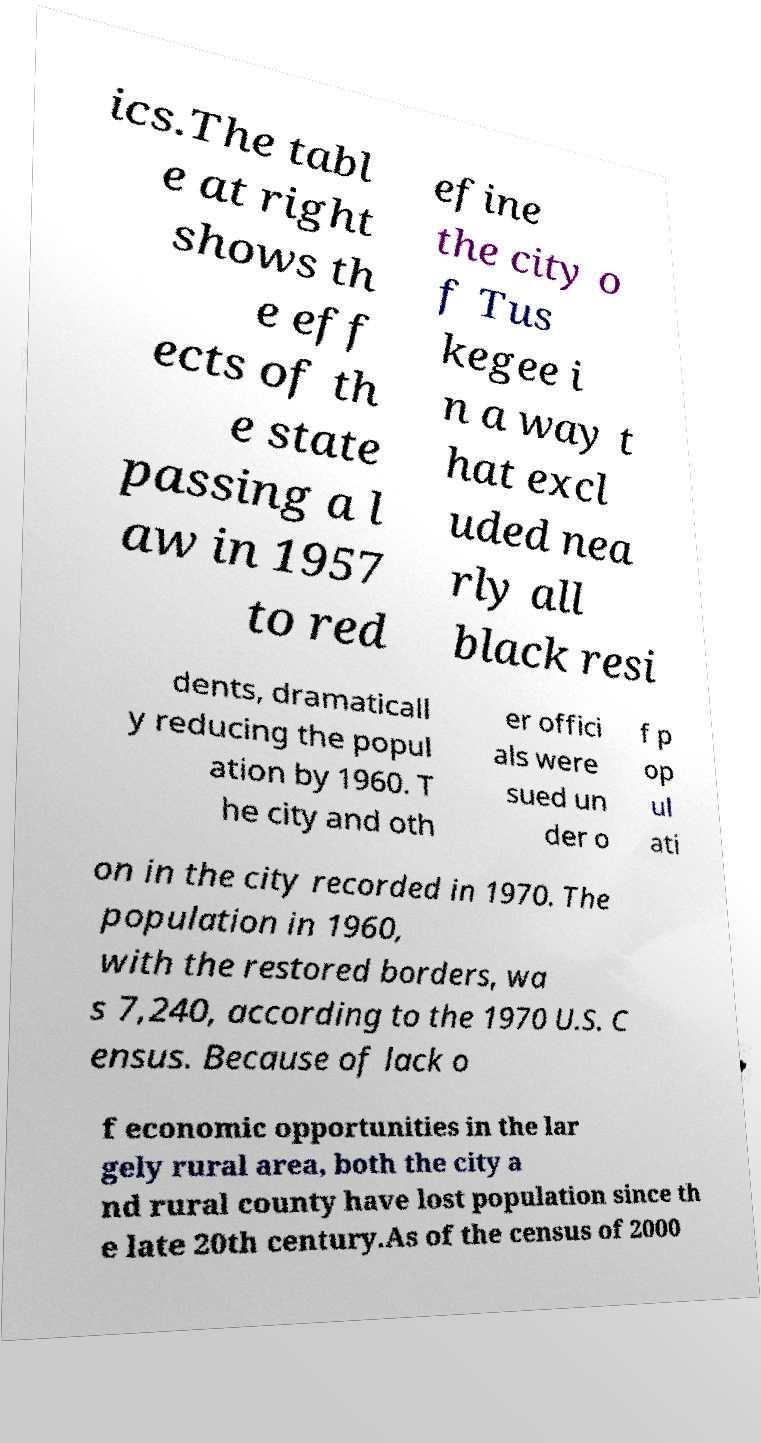There's text embedded in this image that I need extracted. Can you transcribe it verbatim? ics.The tabl e at right shows th e eff ects of th e state passing a l aw in 1957 to red efine the city o f Tus kegee i n a way t hat excl uded nea rly all black resi dents, dramaticall y reducing the popul ation by 1960. T he city and oth er offici als were sued un der o f p op ul ati on in the city recorded in 1970. The population in 1960, with the restored borders, wa s 7,240, according to the 1970 U.S. C ensus. Because of lack o f economic opportunities in the lar gely rural area, both the city a nd rural county have lost population since th e late 20th century.As of the census of 2000 